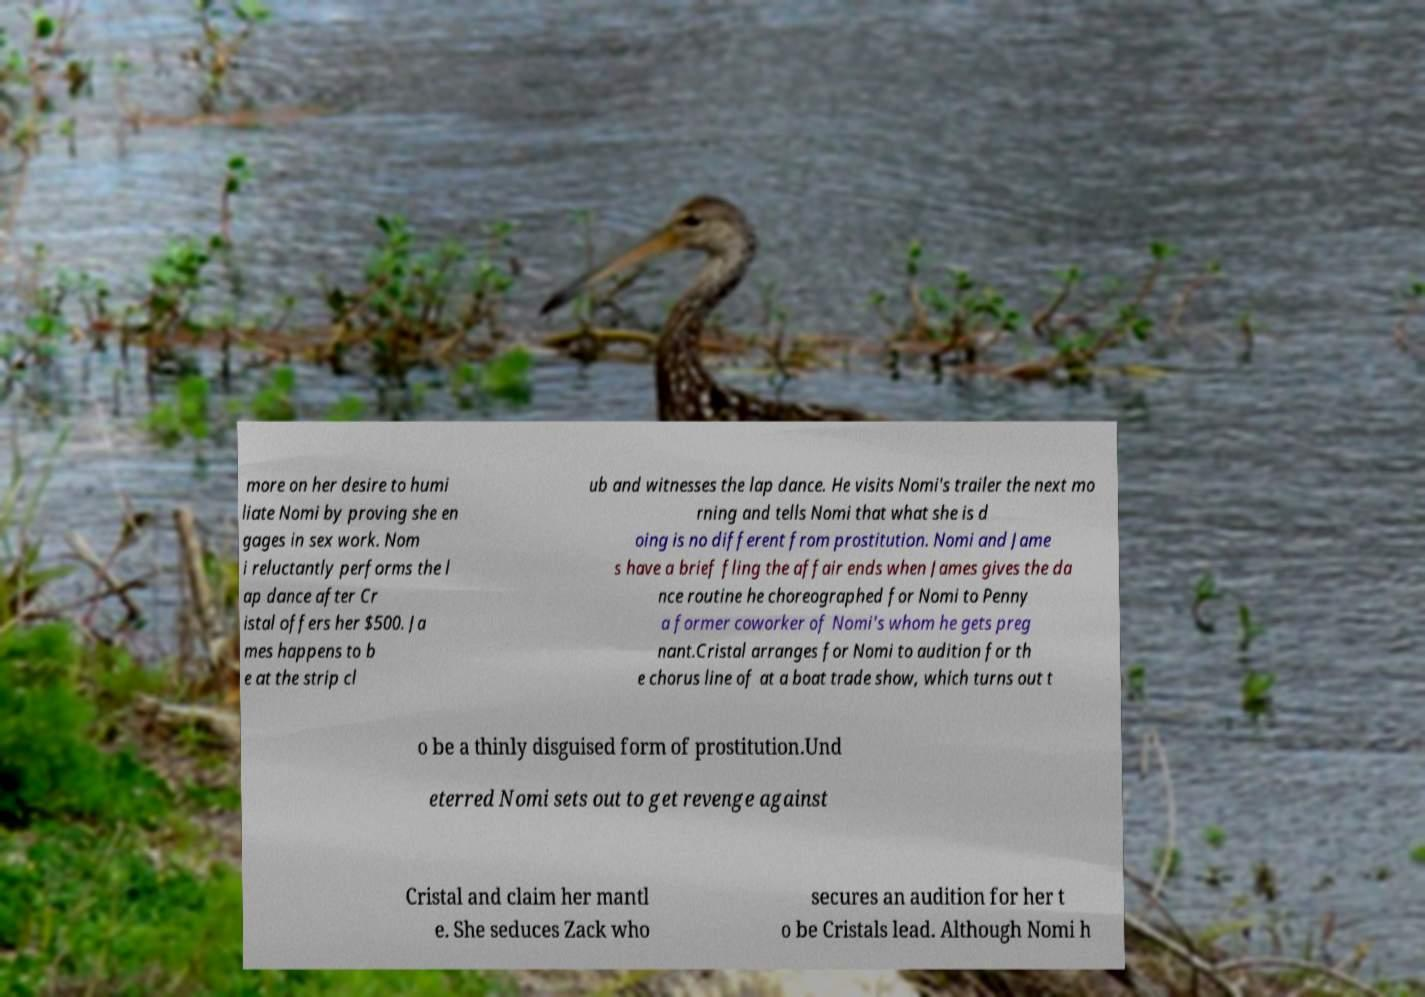I need the written content from this picture converted into text. Can you do that? more on her desire to humi liate Nomi by proving she en gages in sex work. Nom i reluctantly performs the l ap dance after Cr istal offers her $500. Ja mes happens to b e at the strip cl ub and witnesses the lap dance. He visits Nomi's trailer the next mo rning and tells Nomi that what she is d oing is no different from prostitution. Nomi and Jame s have a brief fling the affair ends when James gives the da nce routine he choreographed for Nomi to Penny a former coworker of Nomi's whom he gets preg nant.Cristal arranges for Nomi to audition for th e chorus line of at a boat trade show, which turns out t o be a thinly disguised form of prostitution.Und eterred Nomi sets out to get revenge against Cristal and claim her mantl e. She seduces Zack who secures an audition for her t o be Cristals lead. Although Nomi h 